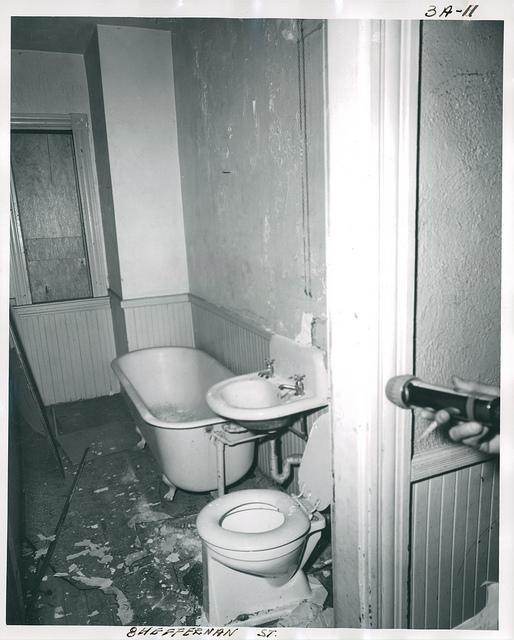How many people are there?
Give a very brief answer. 1. 